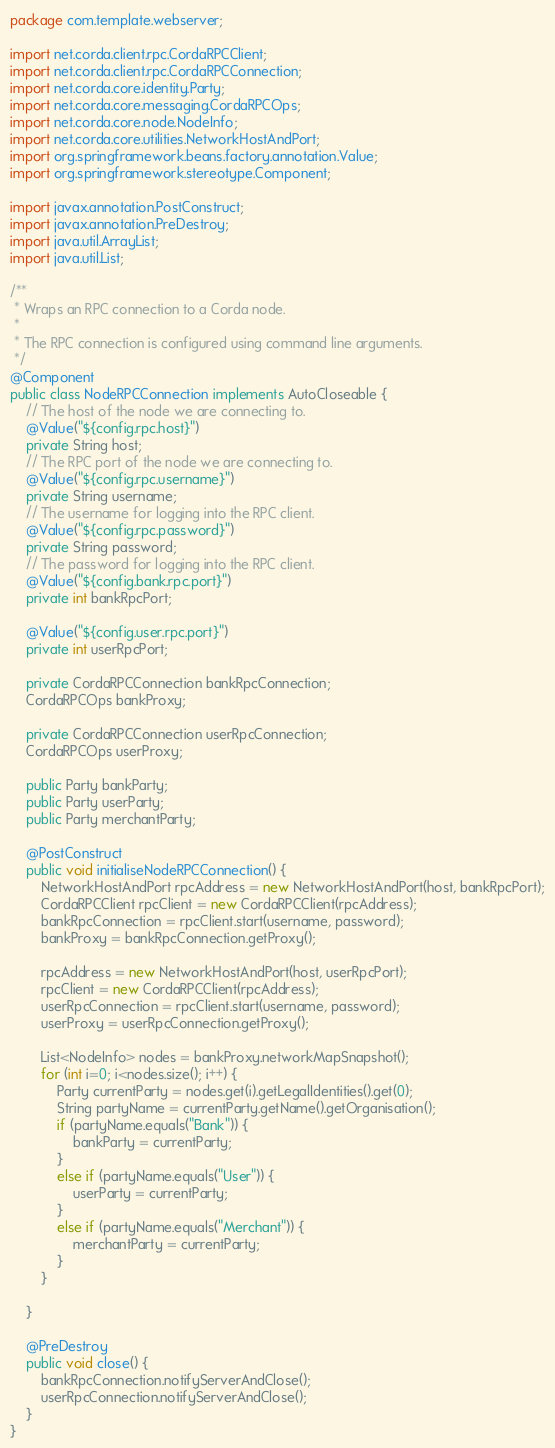<code> <loc_0><loc_0><loc_500><loc_500><_Java_>package com.template.webserver;

import net.corda.client.rpc.CordaRPCClient;
import net.corda.client.rpc.CordaRPCConnection;
import net.corda.core.identity.Party;
import net.corda.core.messaging.CordaRPCOps;
import net.corda.core.node.NodeInfo;
import net.corda.core.utilities.NetworkHostAndPort;
import org.springframework.beans.factory.annotation.Value;
import org.springframework.stereotype.Component;

import javax.annotation.PostConstruct;
import javax.annotation.PreDestroy;
import java.util.ArrayList;
import java.util.List;

/**
 * Wraps an RPC connection to a Corda node.
 *
 * The RPC connection is configured using command line arguments.
 */
@Component
public class NodeRPCConnection implements AutoCloseable {
    // The host of the node we are connecting to.
    @Value("${config.rpc.host}")
    private String host;
    // The RPC port of the node we are connecting to.
    @Value("${config.rpc.username}")
    private String username;
    // The username for logging into the RPC client.
    @Value("${config.rpc.password}")
    private String password;
    // The password for logging into the RPC client.
    @Value("${config.bank.rpc.port}")
    private int bankRpcPort;

    @Value("${config.user.rpc.port}")
    private int userRpcPort;

    private CordaRPCConnection bankRpcConnection;
    CordaRPCOps bankProxy;

    private CordaRPCConnection userRpcConnection;
    CordaRPCOps userProxy;

    public Party bankParty;
    public Party userParty;
    public Party merchantParty;

    @PostConstruct
    public void initialiseNodeRPCConnection() {
        NetworkHostAndPort rpcAddress = new NetworkHostAndPort(host, bankRpcPort);
        CordaRPCClient rpcClient = new CordaRPCClient(rpcAddress);
        bankRpcConnection = rpcClient.start(username, password);
        bankProxy = bankRpcConnection.getProxy();

        rpcAddress = new NetworkHostAndPort(host, userRpcPort);
        rpcClient = new CordaRPCClient(rpcAddress);
        userRpcConnection = rpcClient.start(username, password);
        userProxy = userRpcConnection.getProxy();

        List<NodeInfo> nodes = bankProxy.networkMapSnapshot();
        for (int i=0; i<nodes.size(); i++) {
            Party currentParty = nodes.get(i).getLegalIdentities().get(0);
            String partyName = currentParty.getName().getOrganisation();
            if (partyName.equals("Bank")) {
                bankParty = currentParty;
            }
            else if (partyName.equals("User")) {
                userParty = currentParty;
            }
            else if (partyName.equals("Merchant")) {
                merchantParty = currentParty;
            }
        }

    }

    @PreDestroy
    public void close() {
        bankRpcConnection.notifyServerAndClose();
        userRpcConnection.notifyServerAndClose();
    }
}</code> 